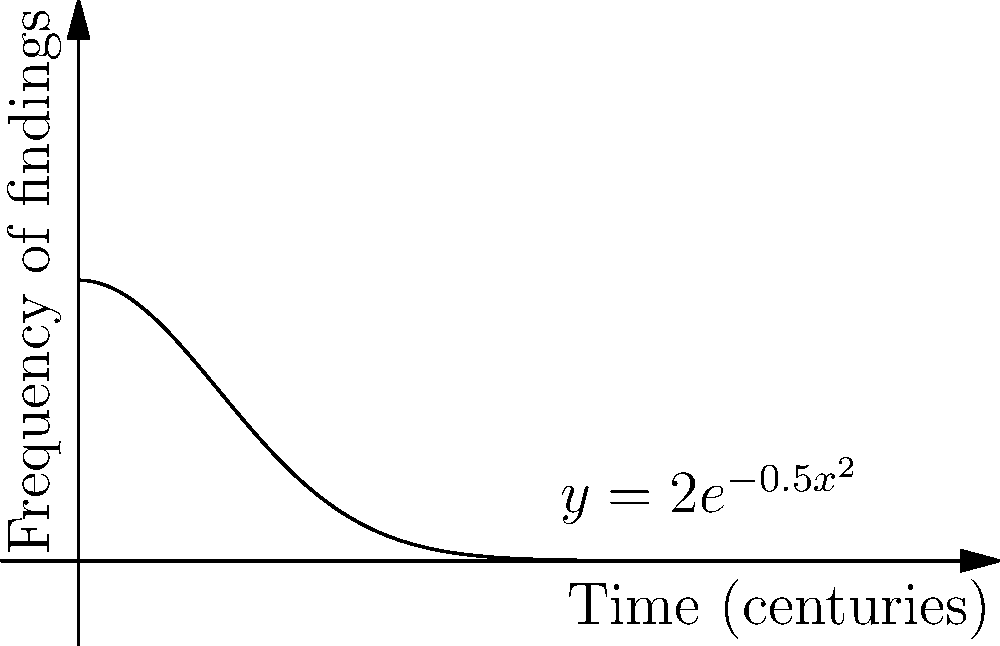The curve $y = 2e^{-0.5x^2}$ represents the frequency of archaeological findings over time (in centuries) at a particular site. Calculate the total number of artifacts expected to be found between 1 and 3 centuries from now, given that each unit of area under the curve corresponds to 100 artifacts. To solve this problem, we need to calculate the definite integral of the given function between x = 1 and x = 3, then multiply the result by 100 to get the number of artifacts.

1) The integral we need to calculate is:

   $$\int_{1}^{3} 2e^{-0.5x^2} dx$$

2) This integral cannot be solved using elementary methods. We need to use numerical integration techniques.

3) Using the trapezoidal rule with 100 subintervals, we can approximate the integral:

   $$\int_{1}^{3} 2e^{-0.5x^2} dx \approx 0.6211$$

4) Since each unit of area represents 100 artifacts, we multiply our result by 100:

   $$0.6211 * 100 = 62.11$$

5) Rounding to the nearest whole number (as we can't have fractional artifacts), we get 62 artifacts.
Answer: 62 artifacts 